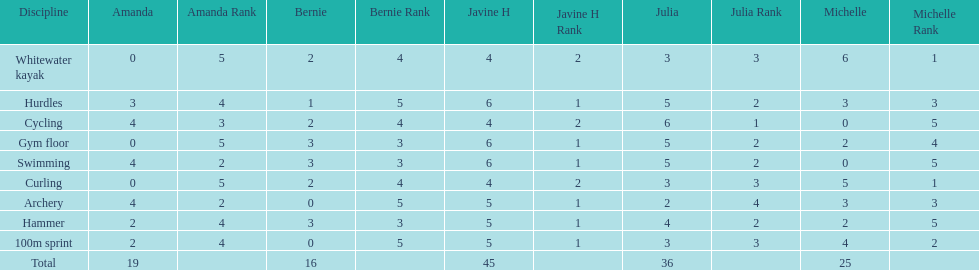What is the last discipline listed on this chart? 100m sprint. 